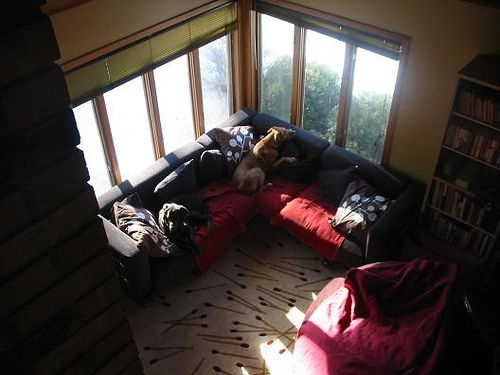Describe the objects in this image and their specific colors. I can see couch in black, maroon, lightgray, and gray tones, couch in black, maroon, white, and lightpink tones, chair in black, maroon, white, and lightpink tones, book in black tones, and dog in black, ivory, gray, and darkgray tones in this image. 